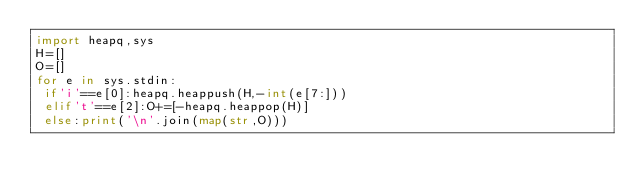Convert code to text. <code><loc_0><loc_0><loc_500><loc_500><_Python_>import heapq,sys
H=[]
O=[]
for e in sys.stdin:
 if'i'==e[0]:heapq.heappush(H,-int(e[7:]))
 elif't'==e[2]:O+=[-heapq.heappop(H)]
 else:print('\n'.join(map(str,O)))
</code> 